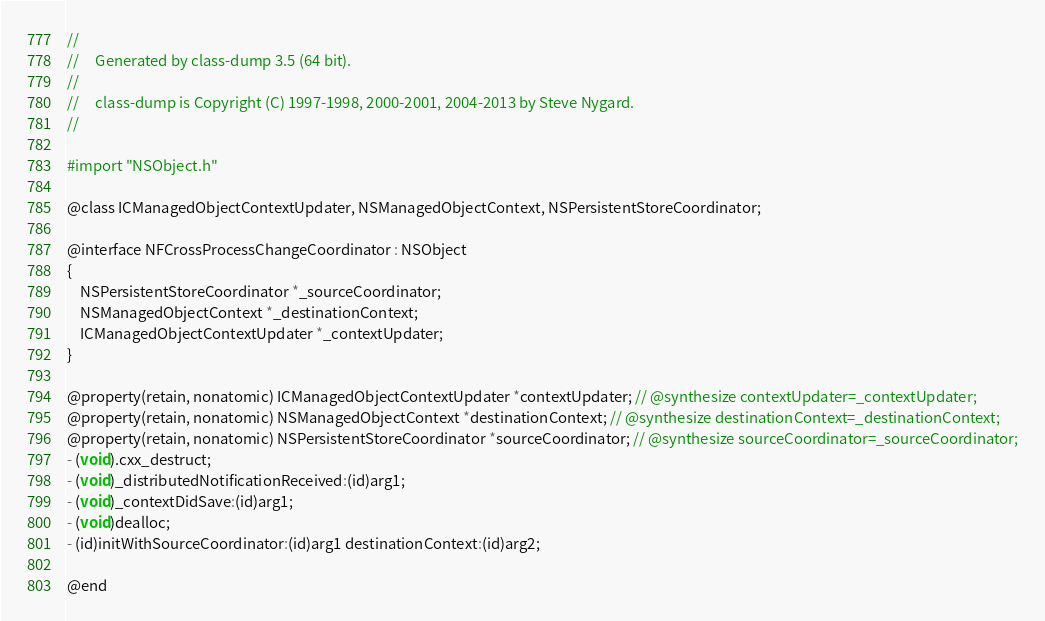Convert code to text. <code><loc_0><loc_0><loc_500><loc_500><_C_>//
//     Generated by class-dump 3.5 (64 bit).
//
//     class-dump is Copyright (C) 1997-1998, 2000-2001, 2004-2013 by Steve Nygard.
//

#import "NSObject.h"

@class ICManagedObjectContextUpdater, NSManagedObjectContext, NSPersistentStoreCoordinator;

@interface NFCrossProcessChangeCoordinator : NSObject
{
    NSPersistentStoreCoordinator *_sourceCoordinator;
    NSManagedObjectContext *_destinationContext;
    ICManagedObjectContextUpdater *_contextUpdater;
}

@property(retain, nonatomic) ICManagedObjectContextUpdater *contextUpdater; // @synthesize contextUpdater=_contextUpdater;
@property(retain, nonatomic) NSManagedObjectContext *destinationContext; // @synthesize destinationContext=_destinationContext;
@property(retain, nonatomic) NSPersistentStoreCoordinator *sourceCoordinator; // @synthesize sourceCoordinator=_sourceCoordinator;
- (void).cxx_destruct;
- (void)_distributedNotificationReceived:(id)arg1;
- (void)_contextDidSave:(id)arg1;
- (void)dealloc;
- (id)initWithSourceCoordinator:(id)arg1 destinationContext:(id)arg2;

@end

</code> 